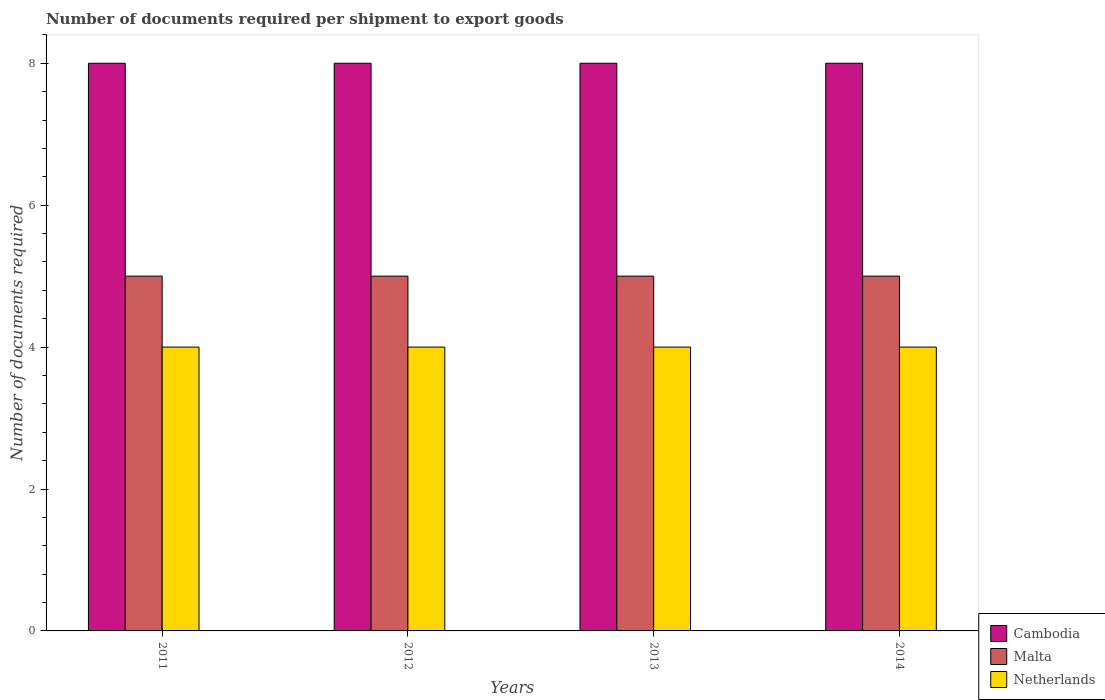How many bars are there on the 4th tick from the right?
Give a very brief answer. 3. What is the label of the 4th group of bars from the left?
Provide a short and direct response. 2014. What is the number of documents required per shipment to export goods in Netherlands in 2011?
Your answer should be very brief. 4. Across all years, what is the maximum number of documents required per shipment to export goods in Cambodia?
Your answer should be very brief. 8. Across all years, what is the minimum number of documents required per shipment to export goods in Cambodia?
Your answer should be very brief. 8. In which year was the number of documents required per shipment to export goods in Cambodia maximum?
Keep it short and to the point. 2011. What is the total number of documents required per shipment to export goods in Netherlands in the graph?
Your answer should be very brief. 16. What is the difference between the number of documents required per shipment to export goods in Netherlands in 2012 and that in 2013?
Your response must be concise. 0. What is the difference between the number of documents required per shipment to export goods in Malta in 2011 and the number of documents required per shipment to export goods in Cambodia in 2013?
Provide a succinct answer. -3. What is the average number of documents required per shipment to export goods in Malta per year?
Your answer should be very brief. 5. In the year 2014, what is the difference between the number of documents required per shipment to export goods in Cambodia and number of documents required per shipment to export goods in Netherlands?
Your response must be concise. 4. Is the difference between the number of documents required per shipment to export goods in Cambodia in 2011 and 2012 greater than the difference between the number of documents required per shipment to export goods in Netherlands in 2011 and 2012?
Keep it short and to the point. No. What is the difference between the highest and the second highest number of documents required per shipment to export goods in Cambodia?
Give a very brief answer. 0. What is the difference between the highest and the lowest number of documents required per shipment to export goods in Malta?
Offer a very short reply. 0. In how many years, is the number of documents required per shipment to export goods in Malta greater than the average number of documents required per shipment to export goods in Malta taken over all years?
Ensure brevity in your answer.  0. Are all the bars in the graph horizontal?
Provide a succinct answer. No. Are the values on the major ticks of Y-axis written in scientific E-notation?
Your response must be concise. No. Where does the legend appear in the graph?
Make the answer very short. Bottom right. How are the legend labels stacked?
Ensure brevity in your answer.  Vertical. What is the title of the graph?
Make the answer very short. Number of documents required per shipment to export goods. Does "Macao" appear as one of the legend labels in the graph?
Your answer should be very brief. No. What is the label or title of the X-axis?
Give a very brief answer. Years. What is the label or title of the Y-axis?
Make the answer very short. Number of documents required. What is the Number of documents required in Netherlands in 2011?
Your response must be concise. 4. What is the Number of documents required in Malta in 2012?
Provide a succinct answer. 5. What is the Number of documents required in Netherlands in 2012?
Ensure brevity in your answer.  4. What is the Number of documents required of Malta in 2013?
Ensure brevity in your answer.  5. What is the Number of documents required of Cambodia in 2014?
Offer a terse response. 8. What is the Number of documents required of Netherlands in 2014?
Provide a succinct answer. 4. Across all years, what is the maximum Number of documents required in Malta?
Your answer should be very brief. 5. Across all years, what is the maximum Number of documents required in Netherlands?
Your response must be concise. 4. Across all years, what is the minimum Number of documents required in Cambodia?
Ensure brevity in your answer.  8. What is the difference between the Number of documents required in Malta in 2011 and that in 2012?
Offer a terse response. 0. What is the difference between the Number of documents required in Cambodia in 2011 and that in 2013?
Your response must be concise. 0. What is the difference between the Number of documents required of Malta in 2011 and that in 2013?
Give a very brief answer. 0. What is the difference between the Number of documents required in Malta in 2011 and that in 2014?
Give a very brief answer. 0. What is the difference between the Number of documents required in Netherlands in 2011 and that in 2014?
Keep it short and to the point. 0. What is the difference between the Number of documents required in Cambodia in 2012 and that in 2013?
Offer a very short reply. 0. What is the difference between the Number of documents required of Malta in 2012 and that in 2014?
Your response must be concise. 0. What is the difference between the Number of documents required in Netherlands in 2012 and that in 2014?
Offer a terse response. 0. What is the difference between the Number of documents required in Malta in 2013 and that in 2014?
Ensure brevity in your answer.  0. What is the difference between the Number of documents required in Malta in 2011 and the Number of documents required in Netherlands in 2013?
Provide a short and direct response. 1. What is the difference between the Number of documents required of Cambodia in 2011 and the Number of documents required of Malta in 2014?
Offer a terse response. 3. What is the difference between the Number of documents required of Cambodia in 2011 and the Number of documents required of Netherlands in 2014?
Offer a very short reply. 4. What is the difference between the Number of documents required in Malta in 2011 and the Number of documents required in Netherlands in 2014?
Your answer should be compact. 1. What is the difference between the Number of documents required of Cambodia in 2012 and the Number of documents required of Malta in 2013?
Give a very brief answer. 3. What is the difference between the Number of documents required in Cambodia in 2012 and the Number of documents required in Netherlands in 2013?
Offer a terse response. 4. What is the difference between the Number of documents required in Cambodia in 2012 and the Number of documents required in Netherlands in 2014?
Offer a terse response. 4. What is the difference between the Number of documents required of Malta in 2012 and the Number of documents required of Netherlands in 2014?
Offer a very short reply. 1. What is the difference between the Number of documents required of Cambodia in 2013 and the Number of documents required of Netherlands in 2014?
Your response must be concise. 4. What is the difference between the Number of documents required in Malta in 2013 and the Number of documents required in Netherlands in 2014?
Offer a very short reply. 1. What is the average Number of documents required of Cambodia per year?
Offer a terse response. 8. What is the average Number of documents required of Malta per year?
Provide a succinct answer. 5. What is the average Number of documents required of Netherlands per year?
Your response must be concise. 4. In the year 2011, what is the difference between the Number of documents required in Cambodia and Number of documents required in Netherlands?
Make the answer very short. 4. In the year 2013, what is the difference between the Number of documents required in Cambodia and Number of documents required in Malta?
Ensure brevity in your answer.  3. In the year 2013, what is the difference between the Number of documents required of Cambodia and Number of documents required of Netherlands?
Provide a succinct answer. 4. In the year 2014, what is the difference between the Number of documents required of Malta and Number of documents required of Netherlands?
Keep it short and to the point. 1. What is the ratio of the Number of documents required of Netherlands in 2011 to that in 2012?
Provide a succinct answer. 1. What is the ratio of the Number of documents required of Netherlands in 2011 to that in 2013?
Provide a short and direct response. 1. What is the ratio of the Number of documents required in Malta in 2011 to that in 2014?
Provide a short and direct response. 1. What is the ratio of the Number of documents required of Cambodia in 2012 to that in 2013?
Keep it short and to the point. 1. What is the ratio of the Number of documents required in Netherlands in 2012 to that in 2013?
Your answer should be compact. 1. What is the ratio of the Number of documents required of Malta in 2012 to that in 2014?
Offer a very short reply. 1. What is the ratio of the Number of documents required of Netherlands in 2012 to that in 2014?
Your answer should be compact. 1. What is the ratio of the Number of documents required in Malta in 2013 to that in 2014?
Ensure brevity in your answer.  1. What is the difference between the highest and the second highest Number of documents required of Malta?
Make the answer very short. 0. What is the difference between the highest and the lowest Number of documents required in Malta?
Your answer should be very brief. 0. 